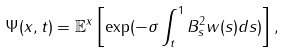Convert formula to latex. <formula><loc_0><loc_0><loc_500><loc_500>\Psi ( x , t ) = { \mathbb { E } } ^ { x } \left [ \exp ( - \sigma \int _ { t } ^ { 1 } B _ { s } ^ { 2 } w ( s ) d s ) \right ] ,</formula> 